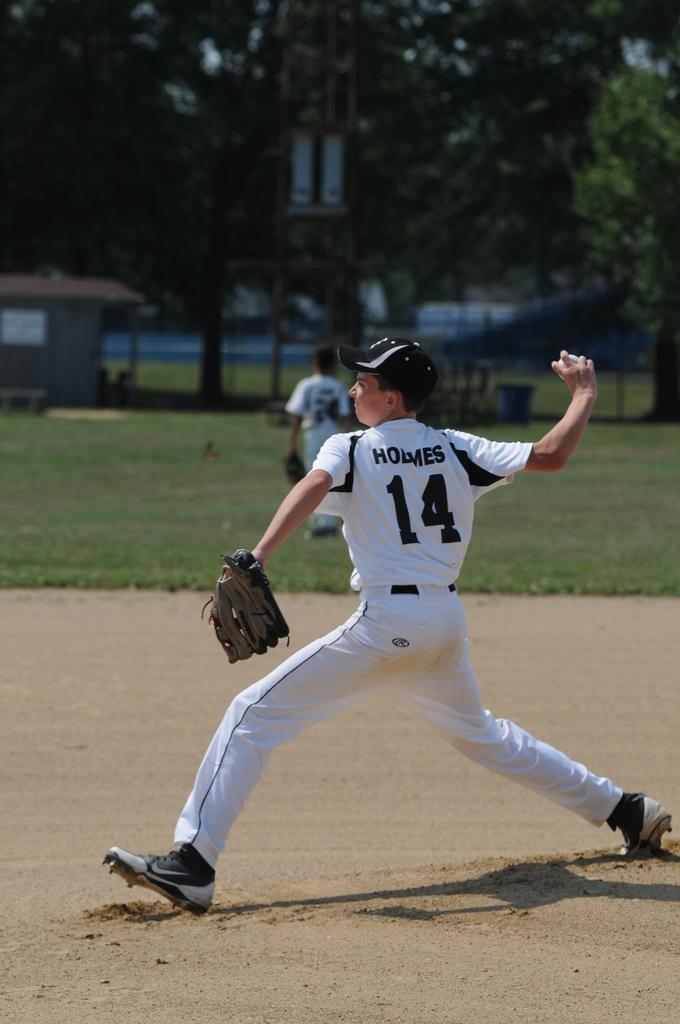<image>
Present a compact description of the photo's key features. a baseball player with the name Holmes and #14 on the jersey in back. 